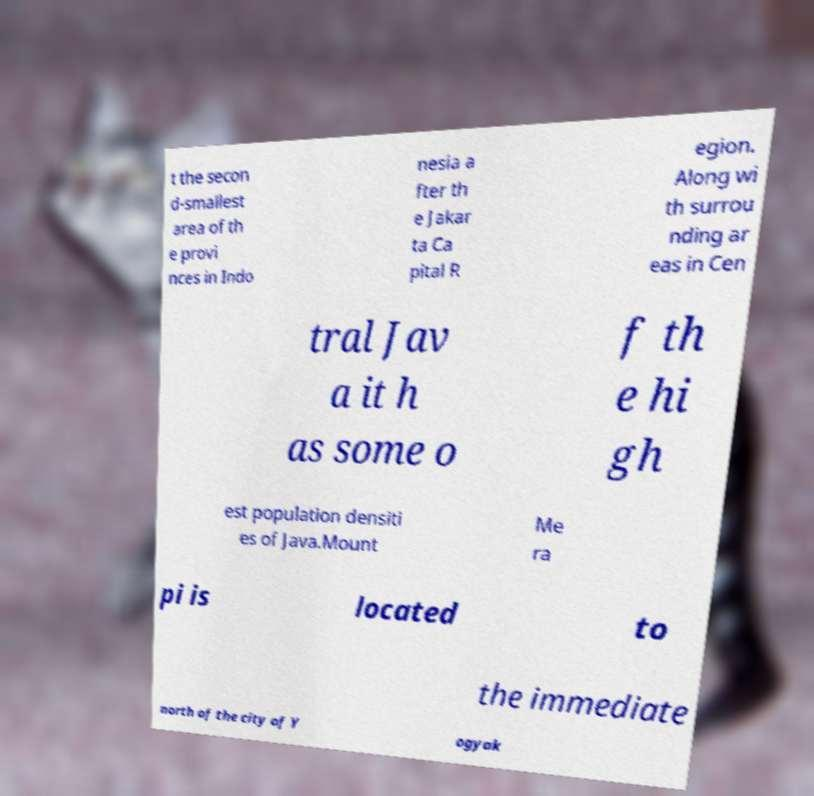Please read and relay the text visible in this image. What does it say? t the secon d-smallest area of th e provi nces in Indo nesia a fter th e Jakar ta Ca pital R egion. Along wi th surrou nding ar eas in Cen tral Jav a it h as some o f th e hi gh est population densiti es of Java.Mount Me ra pi is located to the immediate north of the city of Y ogyak 